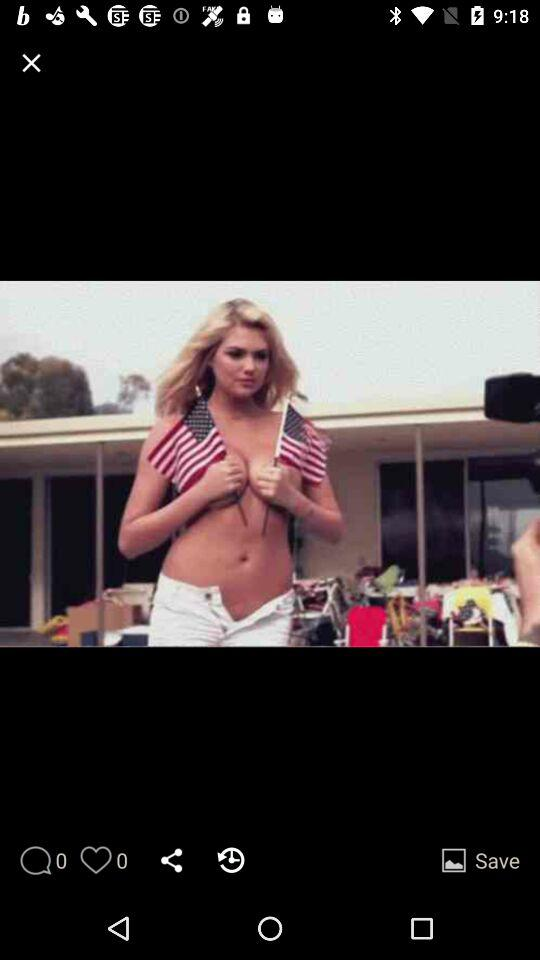What is the message count? The message count is 0. 